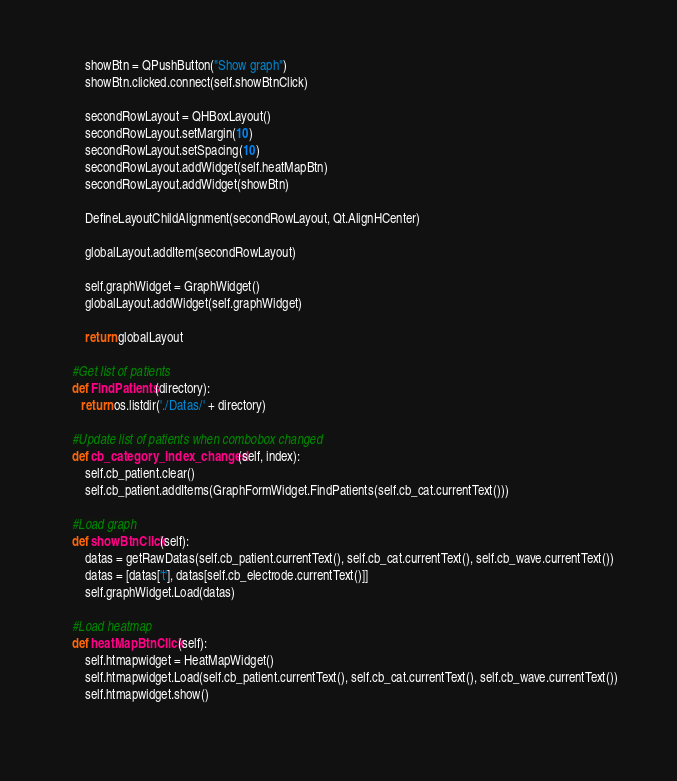Convert code to text. <code><loc_0><loc_0><loc_500><loc_500><_Python_>
        showBtn = QPushButton("Show graph")
        showBtn.clicked.connect(self.showBtnClick)
        
        secondRowLayout = QHBoxLayout()
        secondRowLayout.setMargin(10)
        secondRowLayout.setSpacing(10)
        secondRowLayout.addWidget(self.heatMapBtn)
        secondRowLayout.addWidget(showBtn)
        
        DefineLayoutChildAlignment(secondRowLayout, Qt.AlignHCenter)

        globalLayout.addItem(secondRowLayout)

        self.graphWidget = GraphWidget()
        globalLayout.addWidget(self.graphWidget)                

        return globalLayout

    #Get list of patients
    def FindPatients(directory):
       return os.listdir('./Datas/' + directory)

    #Update list of patients when combobox changed
    def cb_category_index_changed(self, index):
        self.cb_patient.clear()
        self.cb_patient.addItems(GraphFormWidget.FindPatients(self.cb_cat.currentText()))

    #Load graph
    def showBtnClick(self):
        datas = getRawDatas(self.cb_patient.currentText(), self.cb_cat.currentText(), self.cb_wave.currentText())
        datas = [datas['t'], datas[self.cb_electrode.currentText()]]
        self.graphWidget.Load(datas)   

    #Load heatmap
    def heatMapBtnClick(self):
        self.htmapwidget = HeatMapWidget()
        self.htmapwidget.Load(self.cb_patient.currentText(), self.cb_cat.currentText(), self.cb_wave.currentText())
        self.htmapwidget.show()
       </code> 